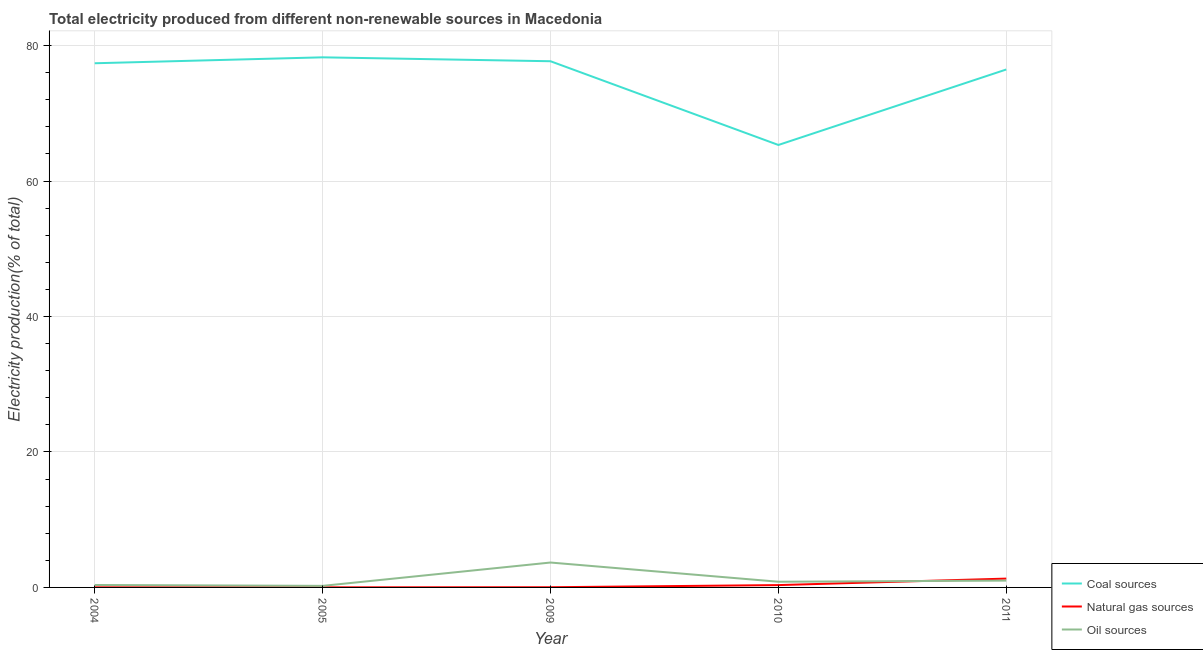How many different coloured lines are there?
Ensure brevity in your answer.  3. What is the percentage of electricity produced by oil sources in 2005?
Your answer should be compact. 0.23. Across all years, what is the maximum percentage of electricity produced by oil sources?
Provide a succinct answer. 3.68. Across all years, what is the minimum percentage of electricity produced by natural gas?
Offer a terse response. 0.01. In which year was the percentage of electricity produced by coal maximum?
Make the answer very short. 2005. In which year was the percentage of electricity produced by coal minimum?
Ensure brevity in your answer.  2010. What is the total percentage of electricity produced by coal in the graph?
Your answer should be very brief. 375.17. What is the difference between the percentage of electricity produced by oil sources in 2005 and that in 2011?
Make the answer very short. -0.78. What is the difference between the percentage of electricity produced by natural gas in 2011 and the percentage of electricity produced by coal in 2005?
Ensure brevity in your answer.  -76.97. What is the average percentage of electricity produced by coal per year?
Provide a short and direct response. 75.03. In the year 2011, what is the difference between the percentage of electricity produced by natural gas and percentage of electricity produced by coal?
Provide a succinct answer. -75.17. In how many years, is the percentage of electricity produced by natural gas greater than 4 %?
Offer a very short reply. 0. What is the ratio of the percentage of electricity produced by natural gas in 2005 to that in 2009?
Your answer should be very brief. 0.49. Is the percentage of electricity produced by oil sources in 2004 less than that in 2009?
Your answer should be very brief. Yes. What is the difference between the highest and the second highest percentage of electricity produced by oil sources?
Your answer should be compact. 2.67. What is the difference between the highest and the lowest percentage of electricity produced by oil sources?
Give a very brief answer. 3.45. Is the percentage of electricity produced by oil sources strictly greater than the percentage of electricity produced by coal over the years?
Your response must be concise. No. Is the percentage of electricity produced by coal strictly less than the percentage of electricity produced by natural gas over the years?
Your answer should be very brief. No. How many lines are there?
Offer a very short reply. 3. How many years are there in the graph?
Give a very brief answer. 5. What is the difference between two consecutive major ticks on the Y-axis?
Provide a short and direct response. 20. Are the values on the major ticks of Y-axis written in scientific E-notation?
Your answer should be very brief. No. What is the title of the graph?
Offer a very short reply. Total electricity produced from different non-renewable sources in Macedonia. Does "Gaseous fuel" appear as one of the legend labels in the graph?
Your answer should be compact. No. What is the label or title of the X-axis?
Ensure brevity in your answer.  Year. What is the Electricity production(% of total) of Coal sources in 2004?
Keep it short and to the point. 77.4. What is the Electricity production(% of total) in Natural gas sources in 2004?
Give a very brief answer. 0.01. What is the Electricity production(% of total) of Oil sources in 2004?
Keep it short and to the point. 0.36. What is the Electricity production(% of total) in Coal sources in 2005?
Your response must be concise. 78.27. What is the Electricity production(% of total) of Natural gas sources in 2005?
Provide a succinct answer. 0.01. What is the Electricity production(% of total) in Oil sources in 2005?
Provide a short and direct response. 0.23. What is the Electricity production(% of total) in Coal sources in 2009?
Provide a short and direct response. 77.69. What is the Electricity production(% of total) of Natural gas sources in 2009?
Ensure brevity in your answer.  0.03. What is the Electricity production(% of total) in Oil sources in 2009?
Make the answer very short. 3.68. What is the Electricity production(% of total) in Coal sources in 2010?
Offer a terse response. 65.33. What is the Electricity production(% of total) of Natural gas sources in 2010?
Make the answer very short. 0.34. What is the Electricity production(% of total) in Oil sources in 2010?
Your answer should be very brief. 0.84. What is the Electricity production(% of total) in Coal sources in 2011?
Give a very brief answer. 76.48. What is the Electricity production(% of total) of Natural gas sources in 2011?
Offer a terse response. 1.3. What is the Electricity production(% of total) in Oil sources in 2011?
Ensure brevity in your answer.  1.01. Across all years, what is the maximum Electricity production(% of total) of Coal sources?
Provide a short and direct response. 78.27. Across all years, what is the maximum Electricity production(% of total) in Natural gas sources?
Offer a terse response. 1.3. Across all years, what is the maximum Electricity production(% of total) in Oil sources?
Give a very brief answer. 3.68. Across all years, what is the minimum Electricity production(% of total) in Coal sources?
Give a very brief answer. 65.33. Across all years, what is the minimum Electricity production(% of total) in Natural gas sources?
Keep it short and to the point. 0.01. Across all years, what is the minimum Electricity production(% of total) of Oil sources?
Keep it short and to the point. 0.23. What is the total Electricity production(% of total) of Coal sources in the graph?
Provide a succinct answer. 375.17. What is the total Electricity production(% of total) of Natural gas sources in the graph?
Offer a terse response. 1.71. What is the total Electricity production(% of total) of Oil sources in the graph?
Make the answer very short. 6.11. What is the difference between the Electricity production(% of total) in Coal sources in 2004 and that in 2005?
Give a very brief answer. -0.88. What is the difference between the Electricity production(% of total) in Natural gas sources in 2004 and that in 2005?
Offer a very short reply. 0. What is the difference between the Electricity production(% of total) in Oil sources in 2004 and that in 2005?
Provide a succinct answer. 0.13. What is the difference between the Electricity production(% of total) of Coal sources in 2004 and that in 2009?
Give a very brief answer. -0.3. What is the difference between the Electricity production(% of total) in Natural gas sources in 2004 and that in 2009?
Make the answer very short. -0.01. What is the difference between the Electricity production(% of total) in Oil sources in 2004 and that in 2009?
Provide a short and direct response. -3.32. What is the difference between the Electricity production(% of total) in Coal sources in 2004 and that in 2010?
Make the answer very short. 12.07. What is the difference between the Electricity production(% of total) in Natural gas sources in 2004 and that in 2010?
Provide a succinct answer. -0.33. What is the difference between the Electricity production(% of total) of Oil sources in 2004 and that in 2010?
Keep it short and to the point. -0.48. What is the difference between the Electricity production(% of total) of Coal sources in 2004 and that in 2011?
Your response must be concise. 0.92. What is the difference between the Electricity production(% of total) in Natural gas sources in 2004 and that in 2011?
Offer a very short reply. -1.29. What is the difference between the Electricity production(% of total) of Oil sources in 2004 and that in 2011?
Offer a very short reply. -0.65. What is the difference between the Electricity production(% of total) in Coal sources in 2005 and that in 2009?
Your answer should be very brief. 0.58. What is the difference between the Electricity production(% of total) of Natural gas sources in 2005 and that in 2009?
Make the answer very short. -0.01. What is the difference between the Electricity production(% of total) of Oil sources in 2005 and that in 2009?
Make the answer very short. -3.45. What is the difference between the Electricity production(% of total) in Coal sources in 2005 and that in 2010?
Your response must be concise. 12.94. What is the difference between the Electricity production(% of total) of Natural gas sources in 2005 and that in 2010?
Offer a very short reply. -0.33. What is the difference between the Electricity production(% of total) in Oil sources in 2005 and that in 2010?
Provide a succinct answer. -0.61. What is the difference between the Electricity production(% of total) in Coal sources in 2005 and that in 2011?
Your response must be concise. 1.8. What is the difference between the Electricity production(% of total) in Natural gas sources in 2005 and that in 2011?
Your answer should be very brief. -1.29. What is the difference between the Electricity production(% of total) of Oil sources in 2005 and that in 2011?
Ensure brevity in your answer.  -0.78. What is the difference between the Electricity production(% of total) in Coal sources in 2009 and that in 2010?
Your answer should be compact. 12.36. What is the difference between the Electricity production(% of total) in Natural gas sources in 2009 and that in 2010?
Provide a succinct answer. -0.32. What is the difference between the Electricity production(% of total) of Oil sources in 2009 and that in 2010?
Provide a short and direct response. 2.84. What is the difference between the Electricity production(% of total) in Coal sources in 2009 and that in 2011?
Your response must be concise. 1.22. What is the difference between the Electricity production(% of total) of Natural gas sources in 2009 and that in 2011?
Offer a very short reply. -1.27. What is the difference between the Electricity production(% of total) of Oil sources in 2009 and that in 2011?
Your response must be concise. 2.67. What is the difference between the Electricity production(% of total) in Coal sources in 2010 and that in 2011?
Keep it short and to the point. -11.15. What is the difference between the Electricity production(% of total) of Natural gas sources in 2010 and that in 2011?
Provide a short and direct response. -0.96. What is the difference between the Electricity production(% of total) of Oil sources in 2010 and that in 2011?
Your answer should be compact. -0.17. What is the difference between the Electricity production(% of total) of Coal sources in 2004 and the Electricity production(% of total) of Natural gas sources in 2005?
Your answer should be very brief. 77.38. What is the difference between the Electricity production(% of total) of Coal sources in 2004 and the Electricity production(% of total) of Oil sources in 2005?
Provide a succinct answer. 77.17. What is the difference between the Electricity production(% of total) of Natural gas sources in 2004 and the Electricity production(% of total) of Oil sources in 2005?
Offer a terse response. -0.22. What is the difference between the Electricity production(% of total) of Coal sources in 2004 and the Electricity production(% of total) of Natural gas sources in 2009?
Offer a very short reply. 77.37. What is the difference between the Electricity production(% of total) of Coal sources in 2004 and the Electricity production(% of total) of Oil sources in 2009?
Provide a succinct answer. 73.72. What is the difference between the Electricity production(% of total) of Natural gas sources in 2004 and the Electricity production(% of total) of Oil sources in 2009?
Give a very brief answer. -3.66. What is the difference between the Electricity production(% of total) in Coal sources in 2004 and the Electricity production(% of total) in Natural gas sources in 2010?
Your answer should be compact. 77.05. What is the difference between the Electricity production(% of total) of Coal sources in 2004 and the Electricity production(% of total) of Oil sources in 2010?
Give a very brief answer. 76.56. What is the difference between the Electricity production(% of total) of Natural gas sources in 2004 and the Electricity production(% of total) of Oil sources in 2010?
Keep it short and to the point. -0.83. What is the difference between the Electricity production(% of total) of Coal sources in 2004 and the Electricity production(% of total) of Natural gas sources in 2011?
Provide a short and direct response. 76.09. What is the difference between the Electricity production(% of total) of Coal sources in 2004 and the Electricity production(% of total) of Oil sources in 2011?
Your answer should be very brief. 76.39. What is the difference between the Electricity production(% of total) of Natural gas sources in 2004 and the Electricity production(% of total) of Oil sources in 2011?
Offer a very short reply. -0.99. What is the difference between the Electricity production(% of total) of Coal sources in 2005 and the Electricity production(% of total) of Natural gas sources in 2009?
Your answer should be very brief. 78.24. What is the difference between the Electricity production(% of total) of Coal sources in 2005 and the Electricity production(% of total) of Oil sources in 2009?
Provide a succinct answer. 74.6. What is the difference between the Electricity production(% of total) of Natural gas sources in 2005 and the Electricity production(% of total) of Oil sources in 2009?
Your response must be concise. -3.66. What is the difference between the Electricity production(% of total) in Coal sources in 2005 and the Electricity production(% of total) in Natural gas sources in 2010?
Ensure brevity in your answer.  77.93. What is the difference between the Electricity production(% of total) in Coal sources in 2005 and the Electricity production(% of total) in Oil sources in 2010?
Offer a very short reply. 77.43. What is the difference between the Electricity production(% of total) in Natural gas sources in 2005 and the Electricity production(% of total) in Oil sources in 2010?
Give a very brief answer. -0.83. What is the difference between the Electricity production(% of total) of Coal sources in 2005 and the Electricity production(% of total) of Natural gas sources in 2011?
Provide a succinct answer. 76.97. What is the difference between the Electricity production(% of total) of Coal sources in 2005 and the Electricity production(% of total) of Oil sources in 2011?
Keep it short and to the point. 77.27. What is the difference between the Electricity production(% of total) in Natural gas sources in 2005 and the Electricity production(% of total) in Oil sources in 2011?
Keep it short and to the point. -0.99. What is the difference between the Electricity production(% of total) of Coal sources in 2009 and the Electricity production(% of total) of Natural gas sources in 2010?
Give a very brief answer. 77.35. What is the difference between the Electricity production(% of total) in Coal sources in 2009 and the Electricity production(% of total) in Oil sources in 2010?
Provide a succinct answer. 76.85. What is the difference between the Electricity production(% of total) of Natural gas sources in 2009 and the Electricity production(% of total) of Oil sources in 2010?
Keep it short and to the point. -0.81. What is the difference between the Electricity production(% of total) of Coal sources in 2009 and the Electricity production(% of total) of Natural gas sources in 2011?
Your answer should be very brief. 76.39. What is the difference between the Electricity production(% of total) in Coal sources in 2009 and the Electricity production(% of total) in Oil sources in 2011?
Offer a very short reply. 76.69. What is the difference between the Electricity production(% of total) in Natural gas sources in 2009 and the Electricity production(% of total) in Oil sources in 2011?
Provide a succinct answer. -0.98. What is the difference between the Electricity production(% of total) in Coal sources in 2010 and the Electricity production(% of total) in Natural gas sources in 2011?
Your answer should be compact. 64.03. What is the difference between the Electricity production(% of total) of Coal sources in 2010 and the Electricity production(% of total) of Oil sources in 2011?
Keep it short and to the point. 64.32. What is the difference between the Electricity production(% of total) in Natural gas sources in 2010 and the Electricity production(% of total) in Oil sources in 2011?
Ensure brevity in your answer.  -0.66. What is the average Electricity production(% of total) in Coal sources per year?
Your answer should be compact. 75.03. What is the average Electricity production(% of total) of Natural gas sources per year?
Offer a very short reply. 0.34. What is the average Electricity production(% of total) of Oil sources per year?
Offer a terse response. 1.22. In the year 2004, what is the difference between the Electricity production(% of total) of Coal sources and Electricity production(% of total) of Natural gas sources?
Offer a terse response. 77.38. In the year 2004, what is the difference between the Electricity production(% of total) of Coal sources and Electricity production(% of total) of Oil sources?
Provide a short and direct response. 77.04. In the year 2004, what is the difference between the Electricity production(% of total) in Natural gas sources and Electricity production(% of total) in Oil sources?
Your response must be concise. -0.34. In the year 2005, what is the difference between the Electricity production(% of total) of Coal sources and Electricity production(% of total) of Natural gas sources?
Provide a succinct answer. 78.26. In the year 2005, what is the difference between the Electricity production(% of total) in Coal sources and Electricity production(% of total) in Oil sources?
Give a very brief answer. 78.04. In the year 2005, what is the difference between the Electricity production(% of total) of Natural gas sources and Electricity production(% of total) of Oil sources?
Ensure brevity in your answer.  -0.22. In the year 2009, what is the difference between the Electricity production(% of total) of Coal sources and Electricity production(% of total) of Natural gas sources?
Offer a very short reply. 77.67. In the year 2009, what is the difference between the Electricity production(% of total) in Coal sources and Electricity production(% of total) in Oil sources?
Your answer should be compact. 74.02. In the year 2009, what is the difference between the Electricity production(% of total) of Natural gas sources and Electricity production(% of total) of Oil sources?
Your answer should be very brief. -3.65. In the year 2010, what is the difference between the Electricity production(% of total) of Coal sources and Electricity production(% of total) of Natural gas sources?
Offer a terse response. 64.99. In the year 2010, what is the difference between the Electricity production(% of total) of Coal sources and Electricity production(% of total) of Oil sources?
Your answer should be compact. 64.49. In the year 2010, what is the difference between the Electricity production(% of total) of Natural gas sources and Electricity production(% of total) of Oil sources?
Give a very brief answer. -0.5. In the year 2011, what is the difference between the Electricity production(% of total) in Coal sources and Electricity production(% of total) in Natural gas sources?
Provide a short and direct response. 75.17. In the year 2011, what is the difference between the Electricity production(% of total) in Coal sources and Electricity production(% of total) in Oil sources?
Offer a very short reply. 75.47. In the year 2011, what is the difference between the Electricity production(% of total) of Natural gas sources and Electricity production(% of total) of Oil sources?
Provide a succinct answer. 0.3. What is the ratio of the Electricity production(% of total) in Coal sources in 2004 to that in 2005?
Provide a succinct answer. 0.99. What is the ratio of the Electricity production(% of total) in Natural gas sources in 2004 to that in 2005?
Keep it short and to the point. 1.04. What is the ratio of the Electricity production(% of total) of Oil sources in 2004 to that in 2005?
Your answer should be compact. 1.56. What is the ratio of the Electricity production(% of total) of Natural gas sources in 2004 to that in 2009?
Provide a short and direct response. 0.51. What is the ratio of the Electricity production(% of total) in Oil sources in 2004 to that in 2009?
Offer a terse response. 0.1. What is the ratio of the Electricity production(% of total) of Coal sources in 2004 to that in 2010?
Your response must be concise. 1.18. What is the ratio of the Electricity production(% of total) in Natural gas sources in 2004 to that in 2010?
Your answer should be very brief. 0.04. What is the ratio of the Electricity production(% of total) in Oil sources in 2004 to that in 2010?
Make the answer very short. 0.43. What is the ratio of the Electricity production(% of total) of Coal sources in 2004 to that in 2011?
Provide a succinct answer. 1.01. What is the ratio of the Electricity production(% of total) in Natural gas sources in 2004 to that in 2011?
Your response must be concise. 0.01. What is the ratio of the Electricity production(% of total) of Oil sources in 2004 to that in 2011?
Offer a very short reply. 0.36. What is the ratio of the Electricity production(% of total) of Coal sources in 2005 to that in 2009?
Your response must be concise. 1.01. What is the ratio of the Electricity production(% of total) in Natural gas sources in 2005 to that in 2009?
Keep it short and to the point. 0.49. What is the ratio of the Electricity production(% of total) in Oil sources in 2005 to that in 2009?
Your response must be concise. 0.06. What is the ratio of the Electricity production(% of total) in Coal sources in 2005 to that in 2010?
Give a very brief answer. 1.2. What is the ratio of the Electricity production(% of total) in Natural gas sources in 2005 to that in 2010?
Keep it short and to the point. 0.04. What is the ratio of the Electricity production(% of total) of Oil sources in 2005 to that in 2010?
Provide a short and direct response. 0.27. What is the ratio of the Electricity production(% of total) in Coal sources in 2005 to that in 2011?
Your answer should be compact. 1.02. What is the ratio of the Electricity production(% of total) of Natural gas sources in 2005 to that in 2011?
Your answer should be compact. 0.01. What is the ratio of the Electricity production(% of total) of Oil sources in 2005 to that in 2011?
Give a very brief answer. 0.23. What is the ratio of the Electricity production(% of total) in Coal sources in 2009 to that in 2010?
Your response must be concise. 1.19. What is the ratio of the Electricity production(% of total) in Natural gas sources in 2009 to that in 2010?
Keep it short and to the point. 0.09. What is the ratio of the Electricity production(% of total) in Oil sources in 2009 to that in 2010?
Provide a succinct answer. 4.38. What is the ratio of the Electricity production(% of total) of Coal sources in 2009 to that in 2011?
Ensure brevity in your answer.  1.02. What is the ratio of the Electricity production(% of total) in Natural gas sources in 2009 to that in 2011?
Make the answer very short. 0.02. What is the ratio of the Electricity production(% of total) in Oil sources in 2009 to that in 2011?
Your answer should be very brief. 3.65. What is the ratio of the Electricity production(% of total) of Coal sources in 2010 to that in 2011?
Your answer should be compact. 0.85. What is the ratio of the Electricity production(% of total) in Natural gas sources in 2010 to that in 2011?
Your response must be concise. 0.26. What is the ratio of the Electricity production(% of total) of Oil sources in 2010 to that in 2011?
Provide a short and direct response. 0.84. What is the difference between the highest and the second highest Electricity production(% of total) in Coal sources?
Offer a terse response. 0.58. What is the difference between the highest and the second highest Electricity production(% of total) in Natural gas sources?
Provide a succinct answer. 0.96. What is the difference between the highest and the second highest Electricity production(% of total) of Oil sources?
Offer a terse response. 2.67. What is the difference between the highest and the lowest Electricity production(% of total) in Coal sources?
Give a very brief answer. 12.94. What is the difference between the highest and the lowest Electricity production(% of total) in Natural gas sources?
Your response must be concise. 1.29. What is the difference between the highest and the lowest Electricity production(% of total) in Oil sources?
Offer a very short reply. 3.45. 